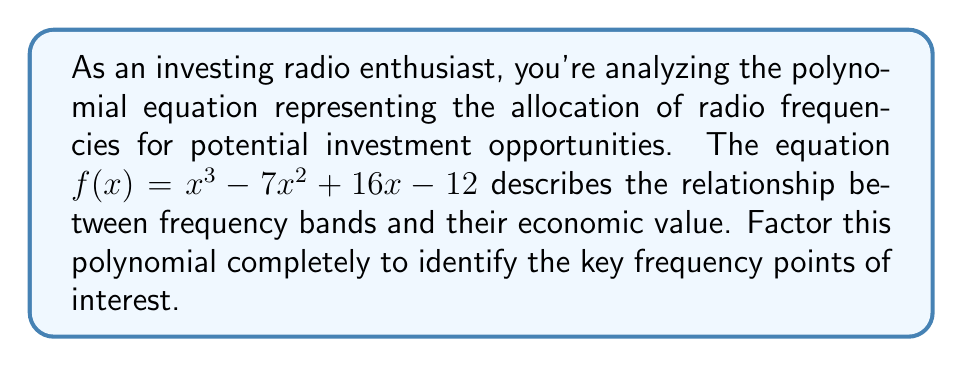Provide a solution to this math problem. Let's approach this step-by-step:

1) First, we'll check if there are any rational roots using the rational root theorem. The possible rational roots are the factors of the constant term: ±1, ±2, ±3, ±4, ±6, ±12.

2) Testing these values, we find that $f(1) = 0$. So $(x-1)$ is a factor.

3) We can use polynomial long division to divide $f(x)$ by $(x-1)$:

   $x^3 - 7x^2 + 16x - 12 = (x-1)(x^2 - 6x + 12)$

4) Now we need to factor the quadratic $x^2 - 6x + 12$. We can use the quadratic formula or recognize it as a perfect square trinomial.

5) $x^2 - 6x + 12 = (x-3)^2$
   This is because $(x-3)^2 = x^2 - 6x + 9$, and $12 - 9 = 3$

6) Therefore, the complete factorization is:

   $f(x) = (x-1)(x-3)^2$

This factorization reveals three key frequency points: one at $x=1$ and a double root at $x=3$, which may indicate a particularly significant frequency in terms of economic value.
Answer: $(x-1)(x-3)^2$ 